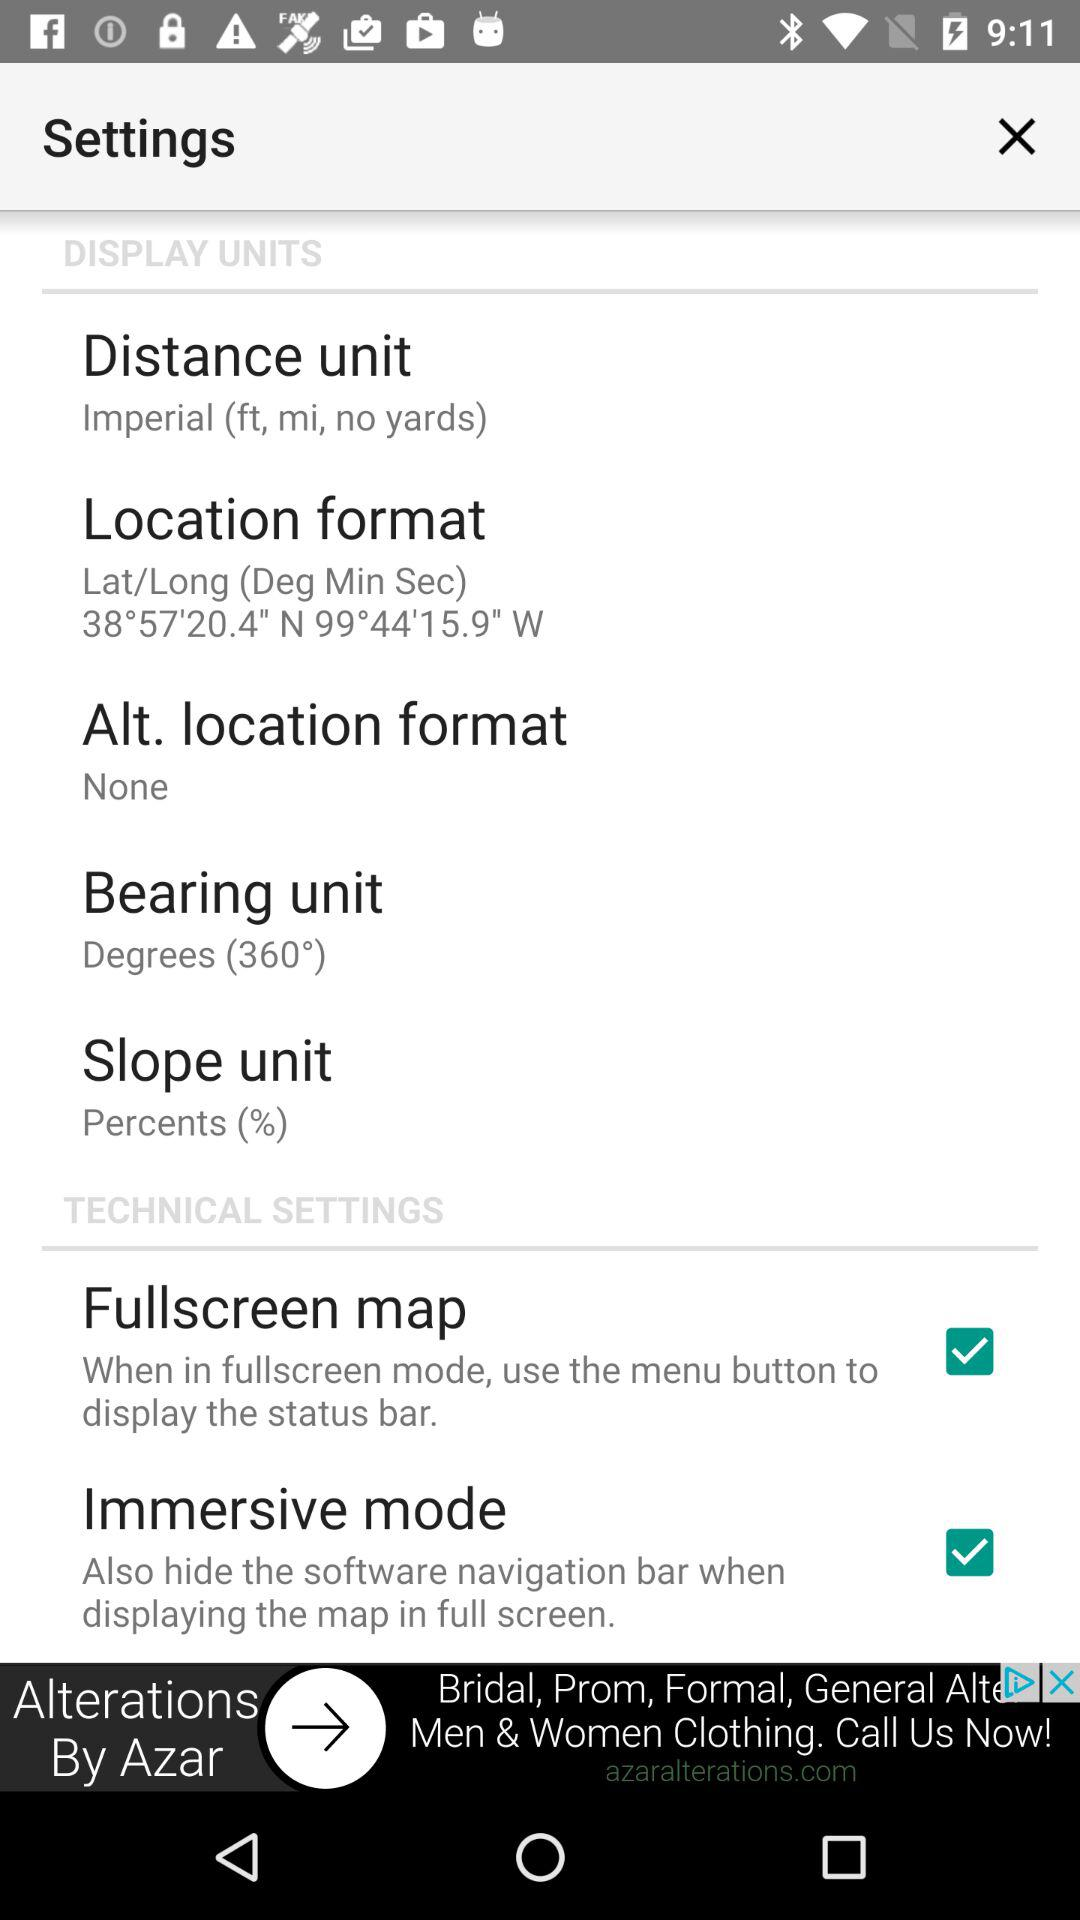How many items are under the Technical Settings section?
Answer the question using a single word or phrase. 2 